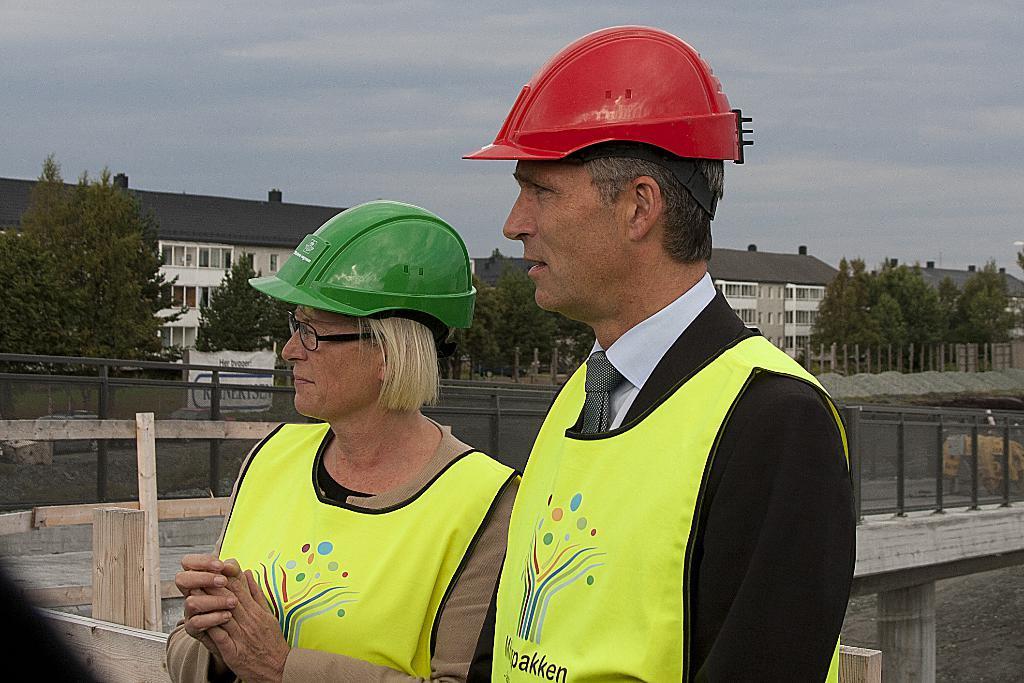How would you summarize this image in a sentence or two? In this picture there are two people standing and wore helmets and we can see fence and bridge. In the background of the image we can see trees, buildings, banner, poles and sky. 